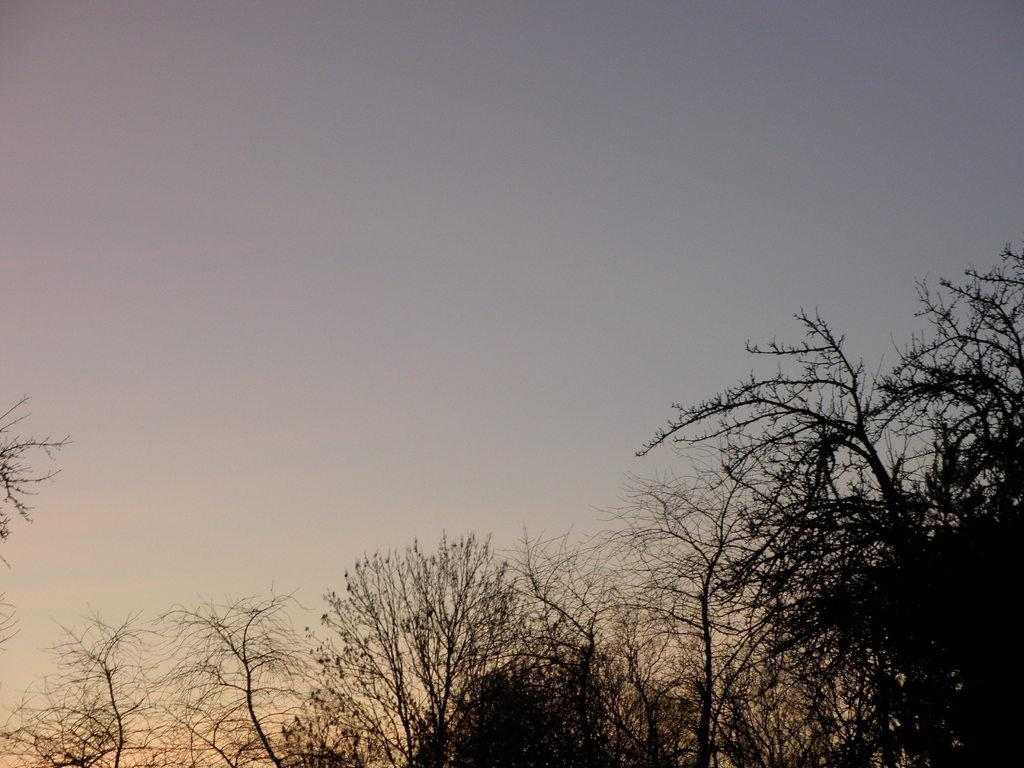What type of vegetation can be seen in the image? There are trees in the image. What color is the sky in the image? The sky is blue in color. Where is the hook located in the image? There is no hook present in the image. What type of structure can be seen in the image? There is no specific structure mentioned in the provided facts; the image only features trees and a blue sky. 